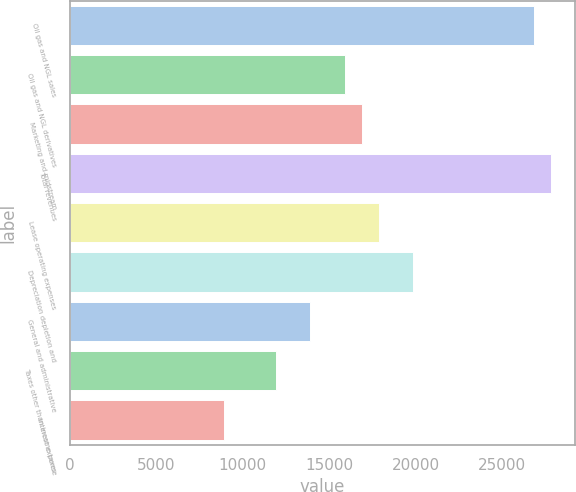Convert chart to OTSL. <chart><loc_0><loc_0><loc_500><loc_500><bar_chart><fcel>Oil gas and NGL sales<fcel>Oil gas and NGL derivatives<fcel>Marketing and midstream<fcel>Total revenues<fcel>Lease operating expenses<fcel>Depreciation depletion and<fcel>General and administrative<fcel>Taxes other than income taxes<fcel>Interest expense<nl><fcel>26834.6<fcel>15902.8<fcel>16896.6<fcel>27828.4<fcel>17890.4<fcel>19878<fcel>13915.2<fcel>11927.6<fcel>8946.2<nl></chart> 